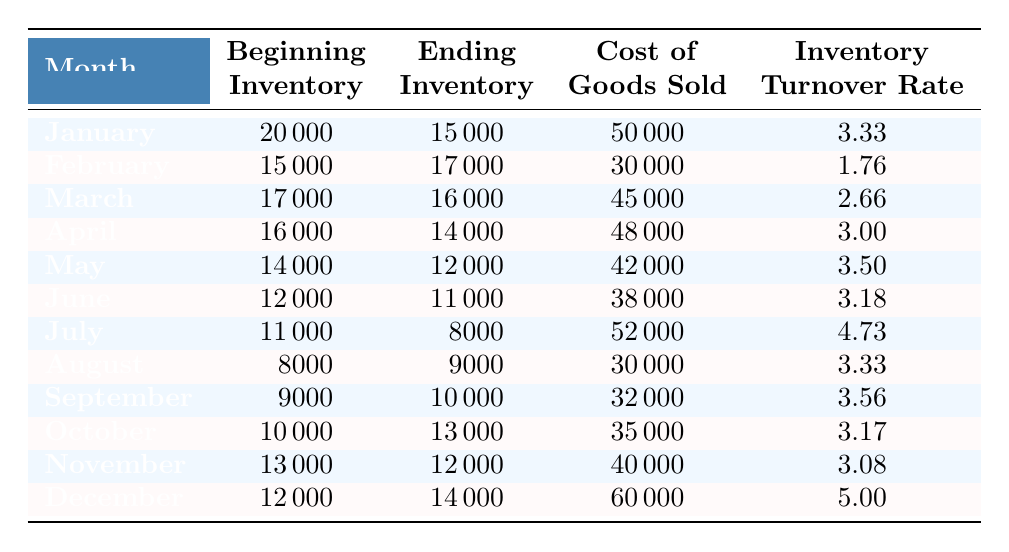What is the inventory turnover rate for July? The table shows that for July, the inventory turnover rate is listed directly under the corresponding month, which is 4.73.
Answer: 4.73 What was the cost of goods sold in February? By looking at the row for February in the table, the cost of goods sold is shown as 30000.
Answer: 30000 What is the average inventory turnover rate for the first half of the year (January to June)? The turnover rates for the first half of the year are 3.33, 1.76, 2.66, 3.00, 3.50, and 3.18. To find the average, we sum these values: 3.33 + 1.76 + 2.66 + 3.00 + 3.50 + 3.18 = 17.43 and then divide by the number of months (6), which is 17.43 / 6 = 2.91.
Answer: 2.91 Is the ending inventory for December higher than for November? We compare the ending inventories for December (14000) and November (12000). Since 14000 is greater than 12000, the statement is true.
Answer: Yes Which month had the highest cost of goods sold? By examining the cost of goods sold column for each month, we see that December has the highest cost at 60000.
Answer: December 